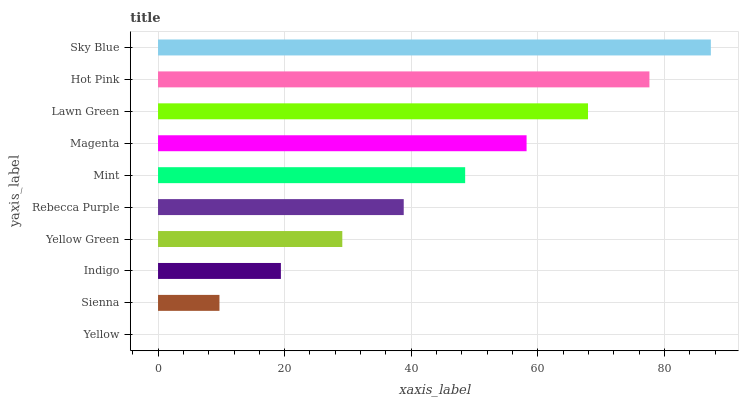Is Yellow the minimum?
Answer yes or no. Yes. Is Sky Blue the maximum?
Answer yes or no. Yes. Is Sienna the minimum?
Answer yes or no. No. Is Sienna the maximum?
Answer yes or no. No. Is Sienna greater than Yellow?
Answer yes or no. Yes. Is Yellow less than Sienna?
Answer yes or no. Yes. Is Yellow greater than Sienna?
Answer yes or no. No. Is Sienna less than Yellow?
Answer yes or no. No. Is Mint the high median?
Answer yes or no. Yes. Is Rebecca Purple the low median?
Answer yes or no. Yes. Is Rebecca Purple the high median?
Answer yes or no. No. Is Sky Blue the low median?
Answer yes or no. No. 